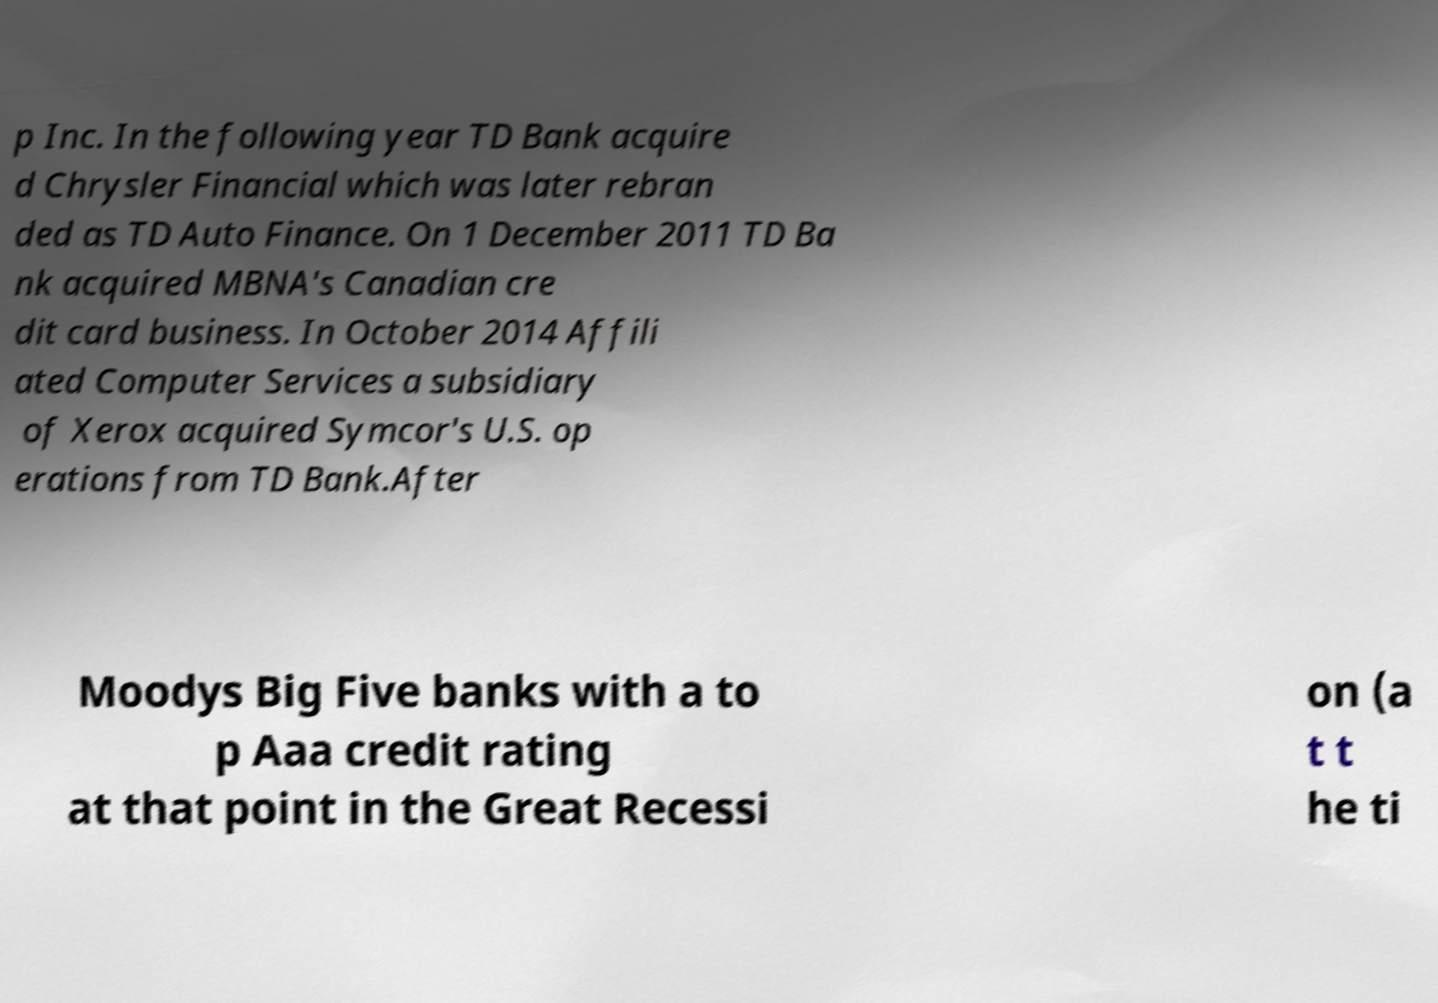Can you accurately transcribe the text from the provided image for me? p Inc. In the following year TD Bank acquire d Chrysler Financial which was later rebran ded as TD Auto Finance. On 1 December 2011 TD Ba nk acquired MBNA's Canadian cre dit card business. In October 2014 Affili ated Computer Services a subsidiary of Xerox acquired Symcor's U.S. op erations from TD Bank.After Moodys Big Five banks with a to p Aaa credit rating at that point in the Great Recessi on (a t t he ti 